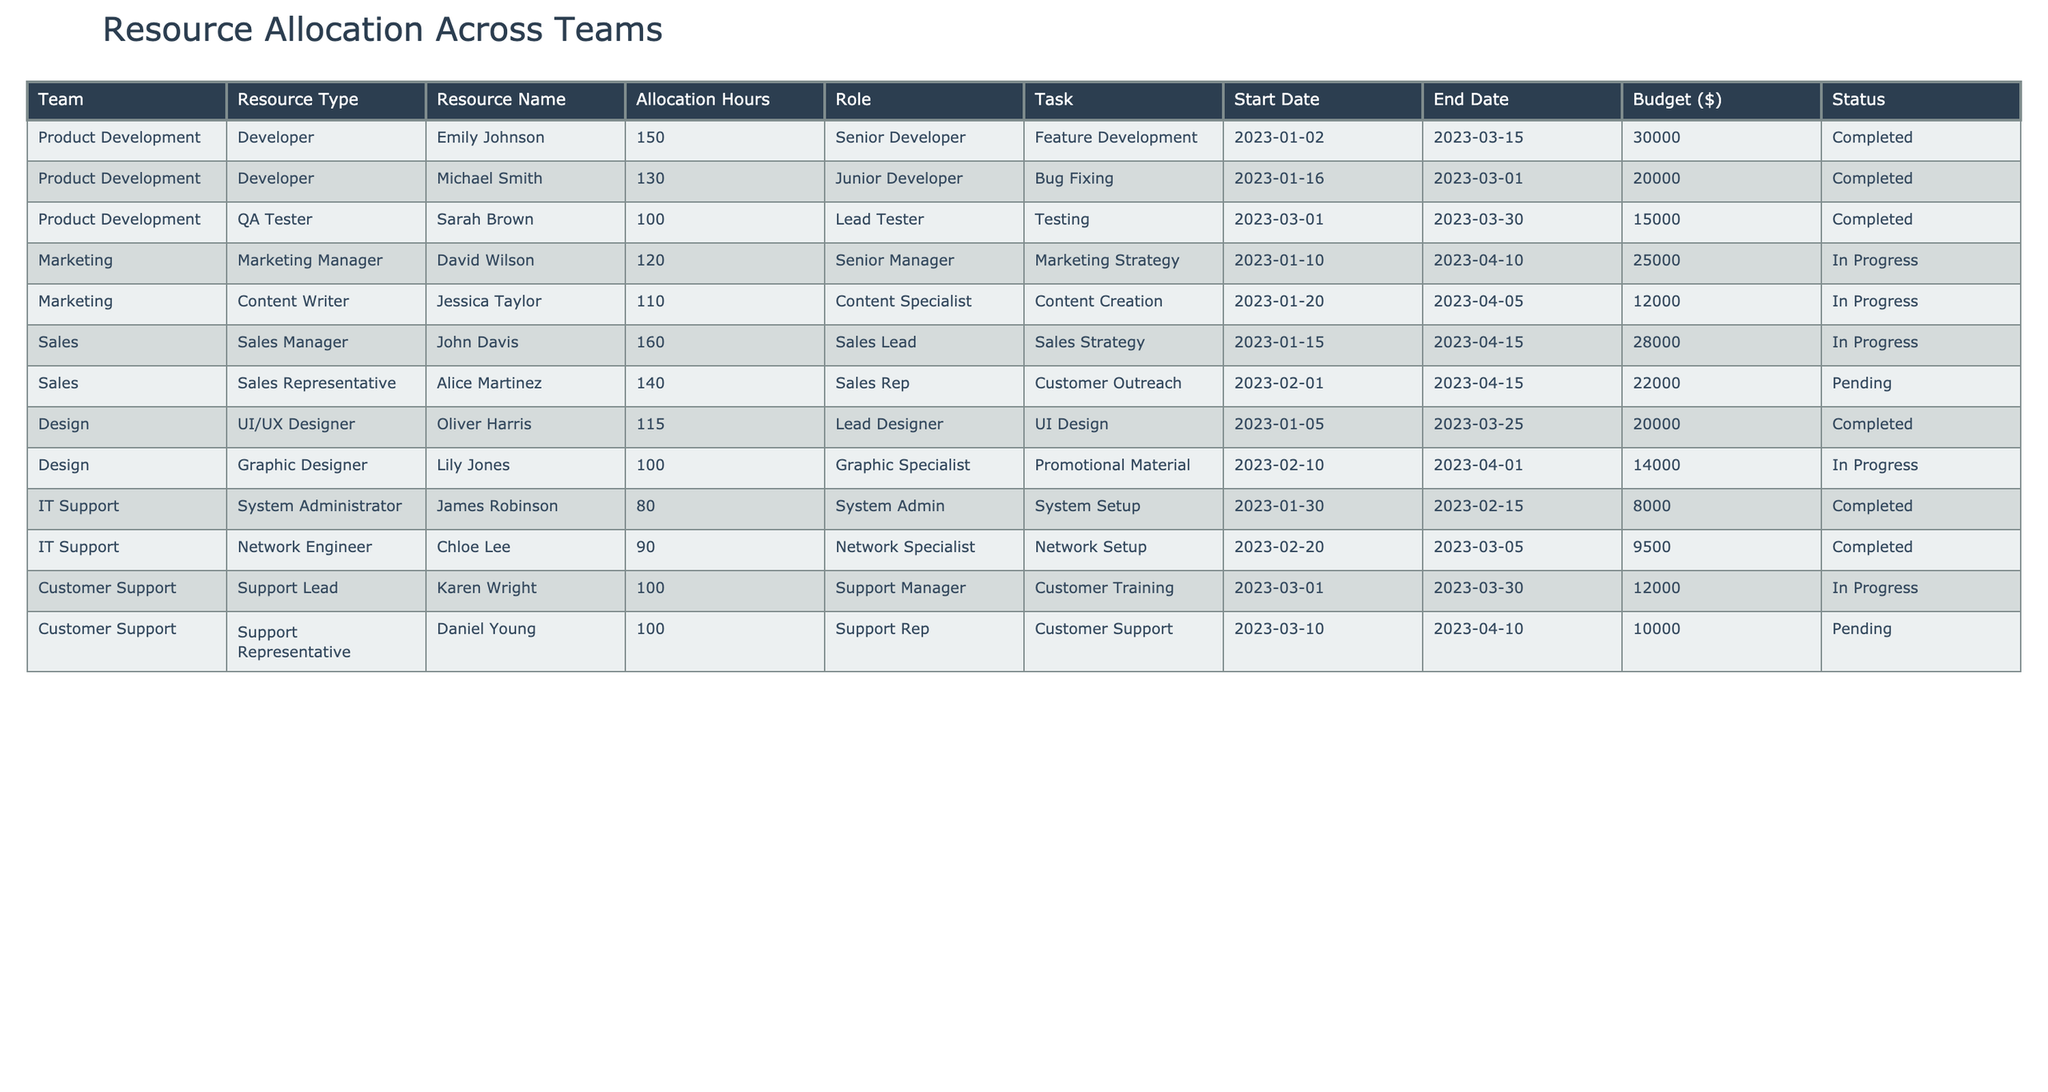What is the total budget allocated for the Marketing team? The Marketing team has two entries: David Wilson with a budget of $25,000 and Jessica Taylor with a budget of $12,000. Adding these gives $25,000 + $12,000 = $37,000.
Answer: $37,000 Which team has the highest allocation of hours? The Sales team has two entries: John Davis with 160 hours and Alice Martinez with 140 hours. The maximum allocation is 160 hours.
Answer: Sales team (160 hours) How many resources are currently pending? There are two pending resources: Alice Martinez and Daniel Young, as indicated in the Status column.
Answer: 2 What is the average allocation hours for the Product Development team? The Product Development team has three entries with 150, 130, and 100 hours. Sum them up: 150 + 130 + 100 = 380, and divide by 3 gives 380/3 = 126.67.
Answer: 126.67 hours Is there any resource allocated for IT Support that is completed? Yes, there are two completed resources in IT Support: James Robinson and Chloe Lee.
Answer: Yes Which resource has the lowest allocation hours in the table? The resource with the lowest allocation is the System Administrator, James Robinson, with 80 hours.
Answer: James Robinson (80 hours) What is the total number of resources allocated for Customer Support? The Customer Support category has two entries: Karen Wright and Daniel Young. So, the total number of resources allocated is 2.
Answer: 2 What is the budget difference between the Design team and the Marketing team? The Design team's budget is $20,000 for Oliver Harris and $14,000 for Lily Jones, totaling $34,000. The Marketing team's budget is $37,000. The difference is $37,000 - $34,000 = $3,000.
Answer: $3,000 How many resources are completed for the Product Development team? The Product Development team has three resources, and all of them are marked as completed, as seen in the Status column.
Answer: 3 What is the overall total budget allocated across all teams? To find the total budget, we sum all budgets: $30,000 + $20,000 + $15,000 + $25,000 + $12,000 + $28,000 + $22,000 + $20,000 + $14,000 + $8,000 + $9,500 + $12,000 + $10,000 = $300,500.
Answer: $300,500 